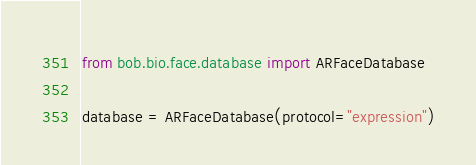<code> <loc_0><loc_0><loc_500><loc_500><_Python_>from bob.bio.face.database import ARFaceDatabase

database = ARFaceDatabase(protocol="expression")
</code> 